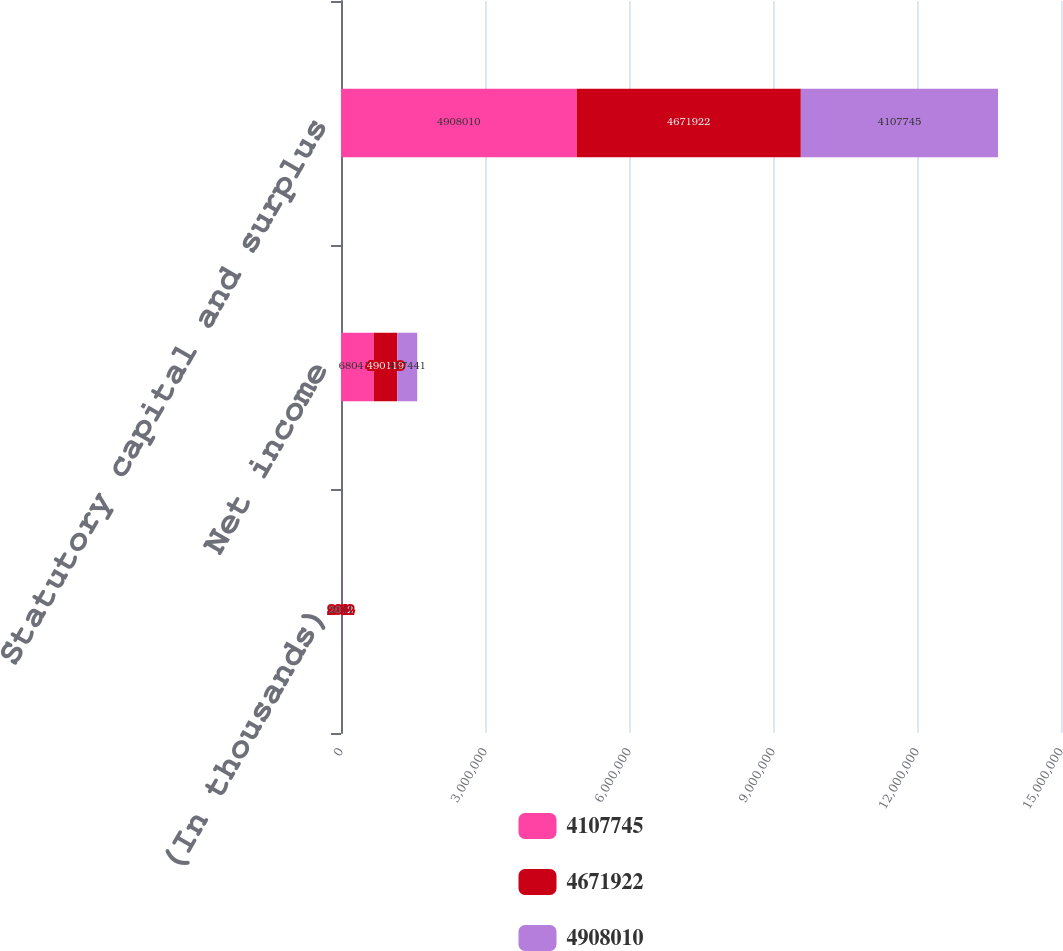Convert chart. <chart><loc_0><loc_0><loc_500><loc_500><stacked_bar_chart><ecel><fcel>(In thousands)<fcel>Net income<fcel>Statutory capital and surplus<nl><fcel>4.10774e+06<fcel>2013<fcel>680418<fcel>4.90801e+06<nl><fcel>4.67192e+06<fcel>2012<fcel>490119<fcel>4.67192e+06<nl><fcel>4.90801e+06<fcel>2011<fcel>417441<fcel>4.10774e+06<nl></chart> 